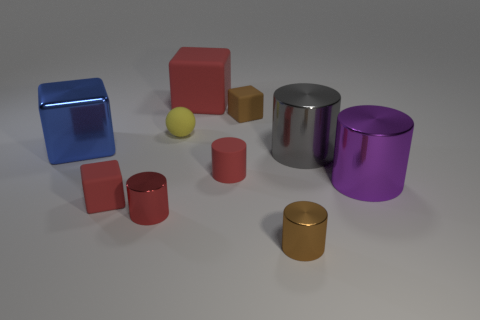Which objects in the image are closest to the yellow sphere? The brown rubber cube and the small red cylinder are the closest objects to the yellow sphere. Could any of these objects be related in terms of their function? It's not possible to determine their function from the image alone, but they could be part of a children's toy set designed for stacking or building, given their shapes and sizes. 